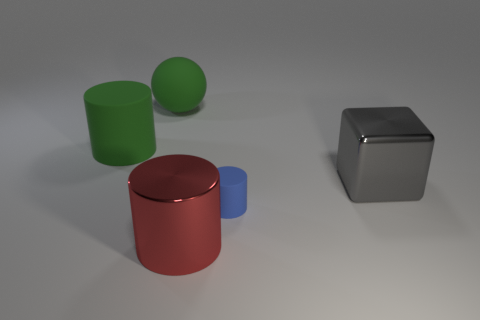Is there any other thing that has the same shape as the large gray object?
Provide a succinct answer. No. There is a metallic thing left of the big gray metallic cube; is it the same color as the big metal object right of the tiny blue rubber cylinder?
Your answer should be compact. No. What number of large red metallic cylinders are left of the large green sphere?
Offer a terse response. 0. There is a large cylinder in front of the large object that is right of the red shiny cylinder; are there any red things behind it?
Offer a terse response. No. What number of other shiny objects are the same size as the red metal thing?
Your response must be concise. 1. There is a large cylinder in front of the big rubber object left of the large green matte sphere; what is it made of?
Your answer should be very brief. Metal. There is a large metal thing that is in front of the matte cylinder that is in front of the big shiny object right of the big metal cylinder; what shape is it?
Your answer should be very brief. Cylinder. There is a green object that is left of the rubber sphere; is its shape the same as the big shiny object in front of the big gray cube?
Make the answer very short. Yes. What number of other things are made of the same material as the big green sphere?
Your response must be concise. 2. There is another object that is the same material as the red object; what shape is it?
Your answer should be very brief. Cube. 